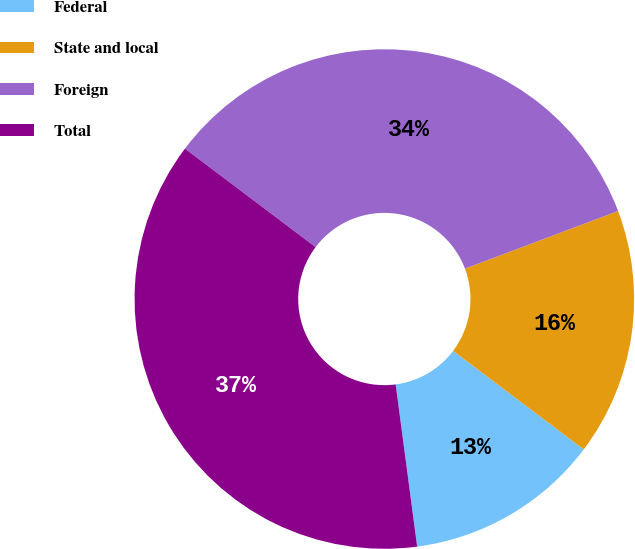<chart> <loc_0><loc_0><loc_500><loc_500><pie_chart><fcel>Federal<fcel>State and local<fcel>Foreign<fcel>Total<nl><fcel>12.62%<fcel>16.02%<fcel>33.98%<fcel>37.38%<nl></chart> 